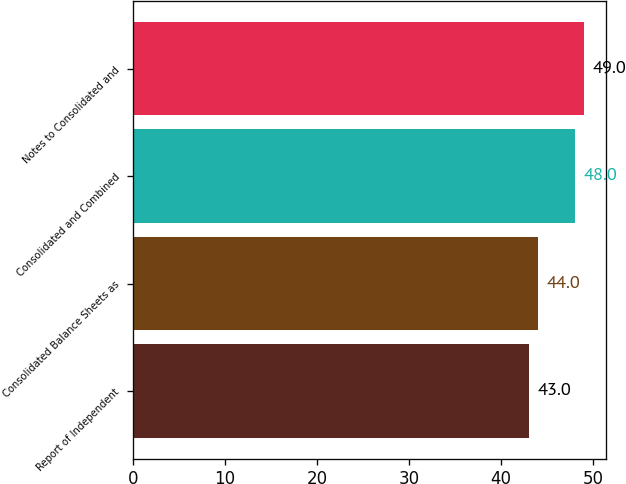Convert chart to OTSL. <chart><loc_0><loc_0><loc_500><loc_500><bar_chart><fcel>Report of Independent<fcel>Consolidated Balance Sheets as<fcel>Consolidated and Combined<fcel>Notes to Consolidated and<nl><fcel>43<fcel>44<fcel>48<fcel>49<nl></chart> 